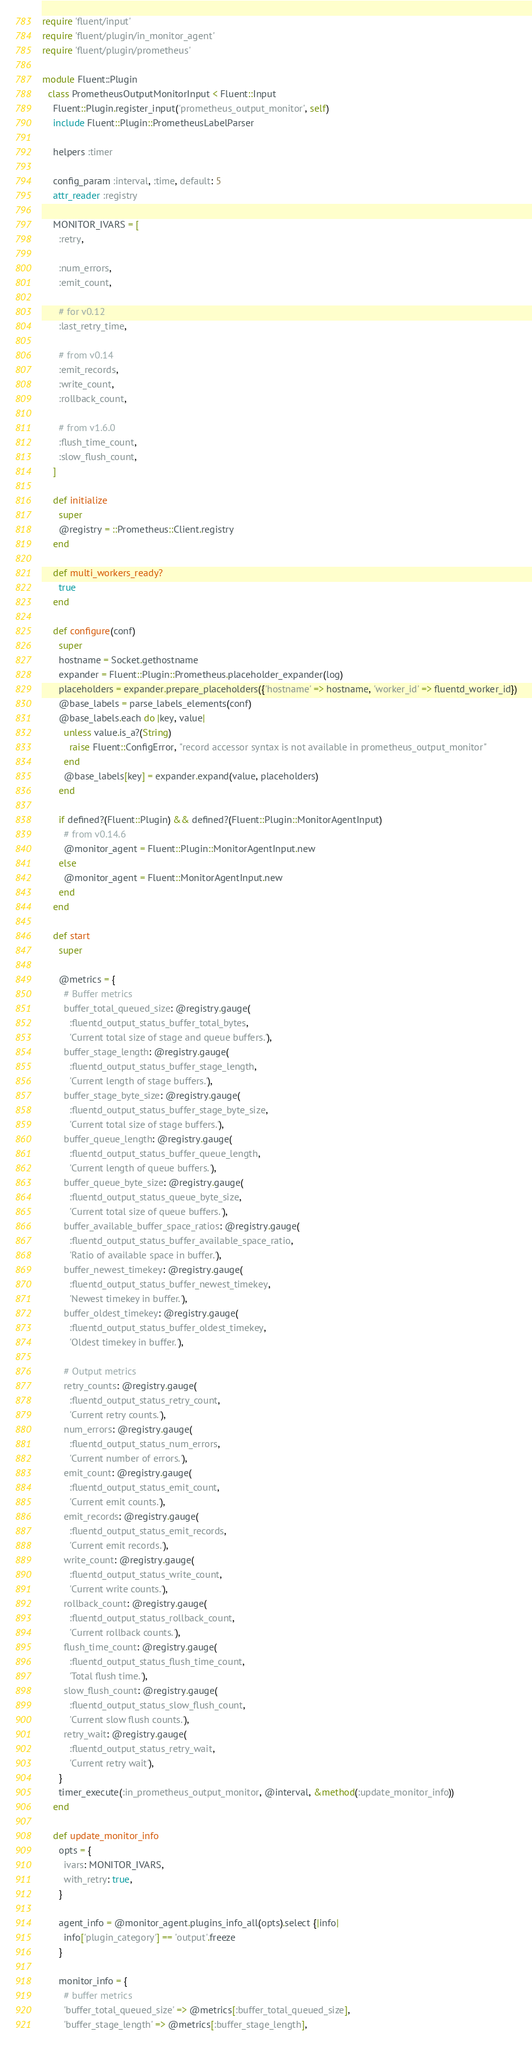<code> <loc_0><loc_0><loc_500><loc_500><_Ruby_>require 'fluent/input'
require 'fluent/plugin/in_monitor_agent'
require 'fluent/plugin/prometheus'

module Fluent::Plugin
  class PrometheusOutputMonitorInput < Fluent::Input
    Fluent::Plugin.register_input('prometheus_output_monitor', self)
    include Fluent::Plugin::PrometheusLabelParser

    helpers :timer

    config_param :interval, :time, default: 5
    attr_reader :registry

    MONITOR_IVARS = [
      :retry,

      :num_errors,
      :emit_count,

      # for v0.12
      :last_retry_time,

      # from v0.14
      :emit_records,
      :write_count,
      :rollback_count,

      # from v1.6.0
      :flush_time_count,
      :slow_flush_count,
    ]

    def initialize
      super
      @registry = ::Prometheus::Client.registry
    end

    def multi_workers_ready?
      true
    end

    def configure(conf)
      super
      hostname = Socket.gethostname
      expander = Fluent::Plugin::Prometheus.placeholder_expander(log)
      placeholders = expander.prepare_placeholders({'hostname' => hostname, 'worker_id' => fluentd_worker_id})
      @base_labels = parse_labels_elements(conf)
      @base_labels.each do |key, value|
        unless value.is_a?(String)
          raise Fluent::ConfigError, "record accessor syntax is not available in prometheus_output_monitor"
        end
        @base_labels[key] = expander.expand(value, placeholders)
      end

      if defined?(Fluent::Plugin) && defined?(Fluent::Plugin::MonitorAgentInput)
        # from v0.14.6
        @monitor_agent = Fluent::Plugin::MonitorAgentInput.new
      else
        @monitor_agent = Fluent::MonitorAgentInput.new
      end
    end

    def start
      super

      @metrics = {
        # Buffer metrics
        buffer_total_queued_size: @registry.gauge(
          :fluentd_output_status_buffer_total_bytes,
          'Current total size of stage and queue buffers.'),
        buffer_stage_length: @registry.gauge(
          :fluentd_output_status_buffer_stage_length,
          'Current length of stage buffers.'),
        buffer_stage_byte_size: @registry.gauge(
          :fluentd_output_status_buffer_stage_byte_size,
          'Current total size of stage buffers.'),
        buffer_queue_length: @registry.gauge(
          :fluentd_output_status_buffer_queue_length,
          'Current length of queue buffers.'),
        buffer_queue_byte_size: @registry.gauge(
          :fluentd_output_status_queue_byte_size,
          'Current total size of queue buffers.'),
        buffer_available_buffer_space_ratios: @registry.gauge(
          :fluentd_output_status_buffer_available_space_ratio,
          'Ratio of available space in buffer.'),
        buffer_newest_timekey: @registry.gauge(
          :fluentd_output_status_buffer_newest_timekey,
          'Newest timekey in buffer.'),
        buffer_oldest_timekey: @registry.gauge(
          :fluentd_output_status_buffer_oldest_timekey,
          'Oldest timekey in buffer.'),

        # Output metrics
        retry_counts: @registry.gauge(
          :fluentd_output_status_retry_count,
          'Current retry counts.'),
        num_errors: @registry.gauge(
          :fluentd_output_status_num_errors,
          'Current number of errors.'),
        emit_count: @registry.gauge(
          :fluentd_output_status_emit_count,
          'Current emit counts.'),
        emit_records: @registry.gauge(
          :fluentd_output_status_emit_records,
          'Current emit records.'),
        write_count: @registry.gauge(
          :fluentd_output_status_write_count,
          'Current write counts.'),
        rollback_count: @registry.gauge(
          :fluentd_output_status_rollback_count,
          'Current rollback counts.'),
        flush_time_count: @registry.gauge(
          :fluentd_output_status_flush_time_count,
          'Total flush time.'),
        slow_flush_count: @registry.gauge(
          :fluentd_output_status_slow_flush_count,
          'Current slow flush counts.'),
        retry_wait: @registry.gauge(
          :fluentd_output_status_retry_wait,
          'Current retry wait'),
      }
      timer_execute(:in_prometheus_output_monitor, @interval, &method(:update_monitor_info))
    end

    def update_monitor_info
      opts = {
        ivars: MONITOR_IVARS,
        with_retry: true,
      }

      agent_info = @monitor_agent.plugins_info_all(opts).select {|info|
        info['plugin_category'] == 'output'.freeze
      }

      monitor_info = {
        # buffer metrics
        'buffer_total_queued_size' => @metrics[:buffer_total_queued_size],
        'buffer_stage_length' => @metrics[:buffer_stage_length],</code> 